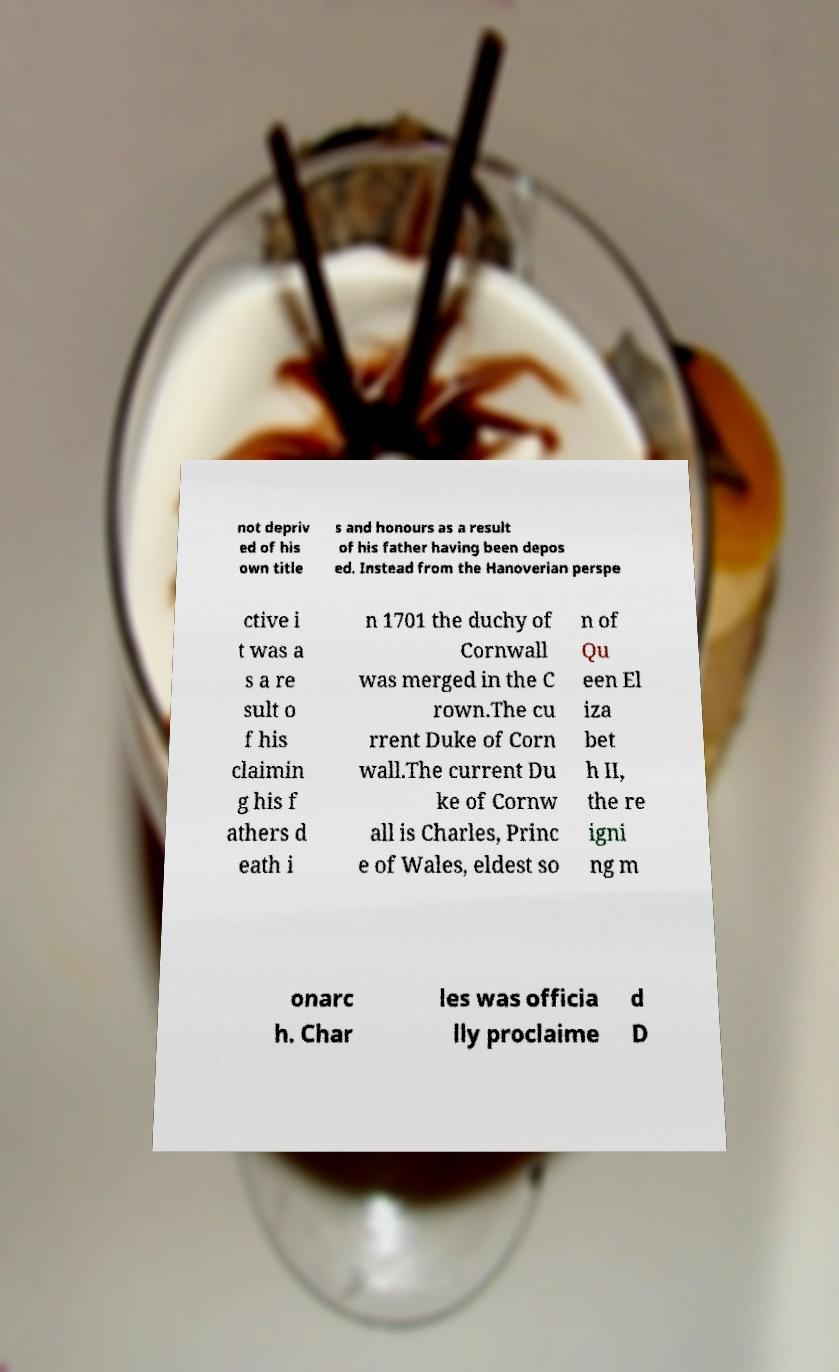I need the written content from this picture converted into text. Can you do that? not depriv ed of his own title s and honours as a result of his father having been depos ed. Instead from the Hanoverian perspe ctive i t was a s a re sult o f his claimin g his f athers d eath i n 1701 the duchy of Cornwall was merged in the C rown.The cu rrent Duke of Corn wall.The current Du ke of Cornw all is Charles, Princ e of Wales, eldest so n of Qu een El iza bet h II, the re igni ng m onarc h. Char les was officia lly proclaime d D 